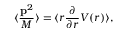Convert formula to latex. <formula><loc_0><loc_0><loc_500><loc_500>\langle { \frac { { p } ^ { 2 } } { M } } \rangle = \langle r { \frac { \partial } { \partial r } } V ( r ) \rangle ,</formula> 